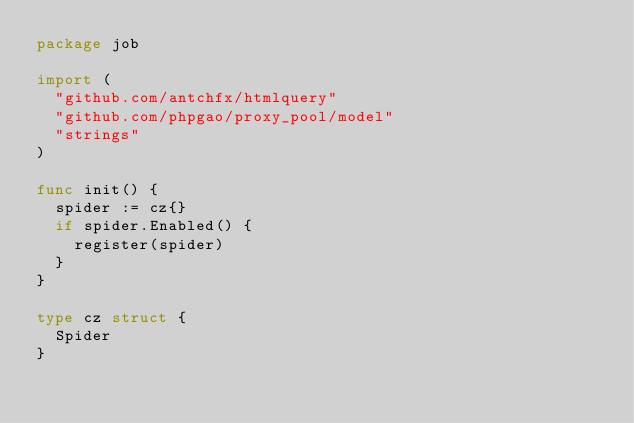<code> <loc_0><loc_0><loc_500><loc_500><_Go_>package job

import (
	"github.com/antchfx/htmlquery"
	"github.com/phpgao/proxy_pool/model"
	"strings"
)

func init() {
	spider := cz{}
	if spider.Enabled() {
		register(spider)
	}
}

type cz struct {
	Spider
}
</code> 